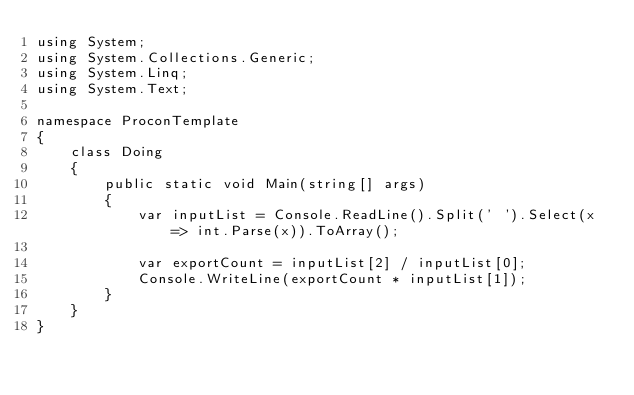<code> <loc_0><loc_0><loc_500><loc_500><_C#_>using System;
using System.Collections.Generic;
using System.Linq;
using System.Text;

namespace ProconTemplate
{
    class Doing
    {
        public static void Main(string[] args)
        {
            var inputList = Console.ReadLine().Split(' ').Select(x => int.Parse(x)).ToArray();

            var exportCount = inputList[2] / inputList[0];
            Console.WriteLine(exportCount * inputList[1]);
        }
    }
}
</code> 